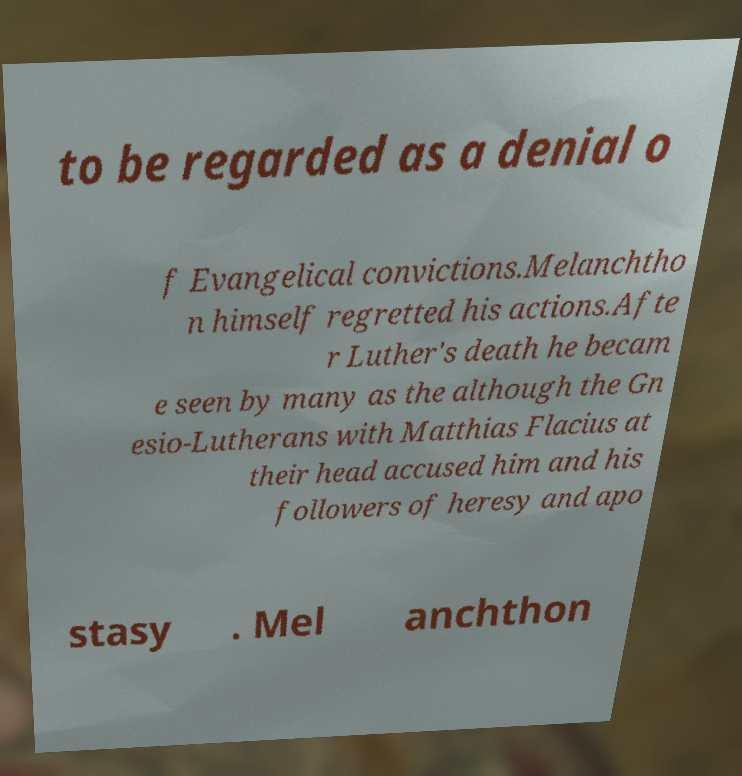Please read and relay the text visible in this image. What does it say? to be regarded as a denial o f Evangelical convictions.Melanchtho n himself regretted his actions.Afte r Luther's death he becam e seen by many as the although the Gn esio-Lutherans with Matthias Flacius at their head accused him and his followers of heresy and apo stasy . Mel anchthon 